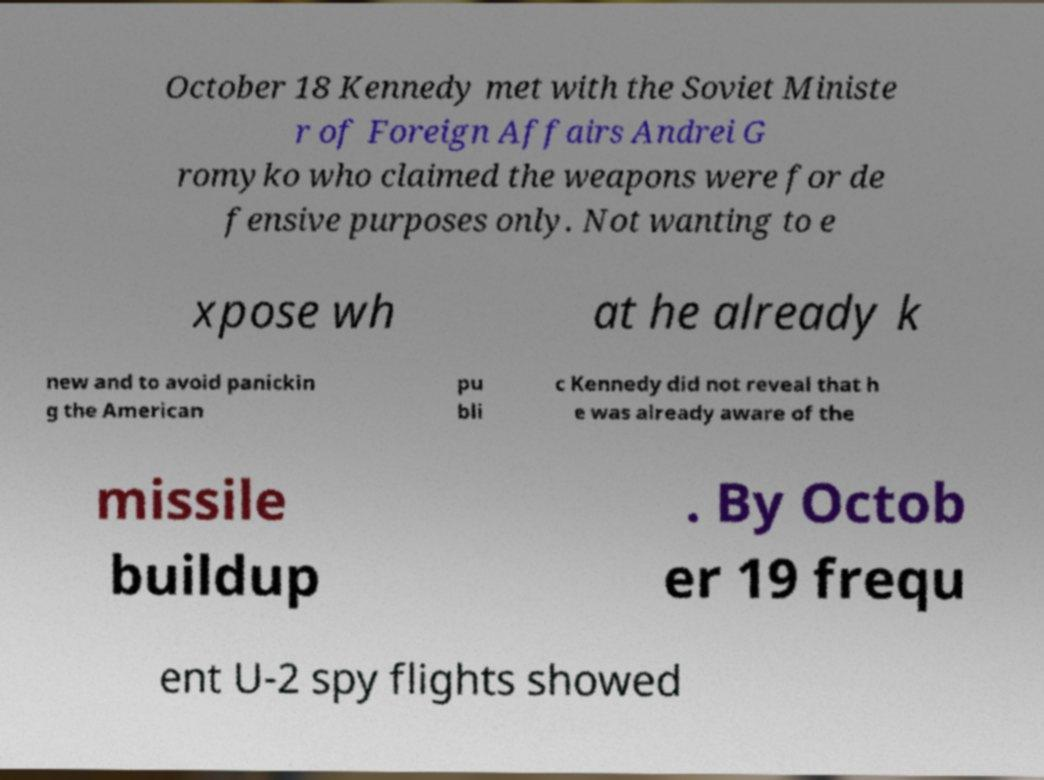Could you extract and type out the text from this image? October 18 Kennedy met with the Soviet Ministe r of Foreign Affairs Andrei G romyko who claimed the weapons were for de fensive purposes only. Not wanting to e xpose wh at he already k new and to avoid panickin g the American pu bli c Kennedy did not reveal that h e was already aware of the missile buildup . By Octob er 19 frequ ent U-2 spy flights showed 